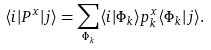<formula> <loc_0><loc_0><loc_500><loc_500>\langle i | P ^ { x } | j \rangle = \sum _ { \Phi _ { k } } \langle i | \Phi _ { k } \rangle p _ { k } ^ { x } \langle \Phi _ { k } | j \rangle .</formula> 